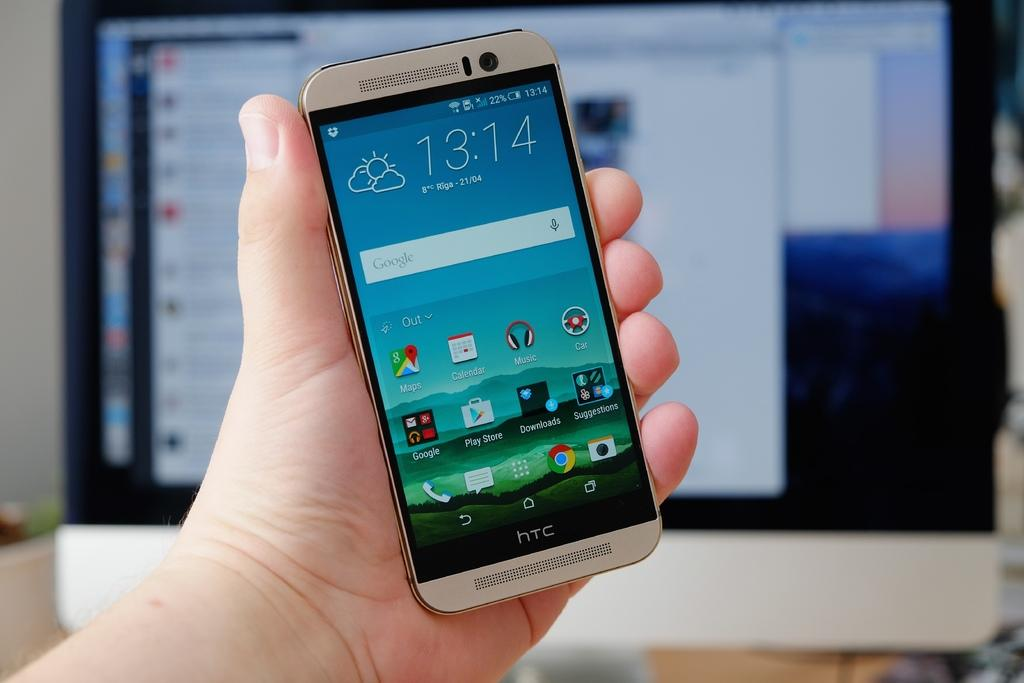<image>
Offer a succinct explanation of the picture presented. An HTC cell phone with the time displayed as 13:14. 